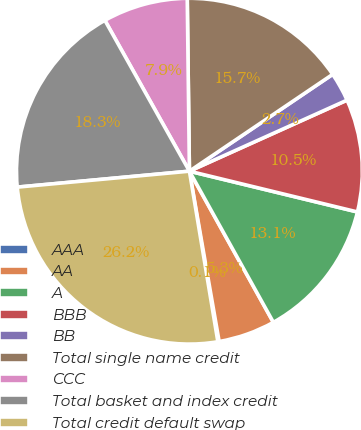Convert chart. <chart><loc_0><loc_0><loc_500><loc_500><pie_chart><fcel>AAA<fcel>AA<fcel>A<fcel>BBB<fcel>BB<fcel>Total single name credit<fcel>CCC<fcel>Total basket and index credit<fcel>Total credit default swap<nl><fcel>0.12%<fcel>5.32%<fcel>13.14%<fcel>10.53%<fcel>2.72%<fcel>15.74%<fcel>7.93%<fcel>18.34%<fcel>26.16%<nl></chart> 